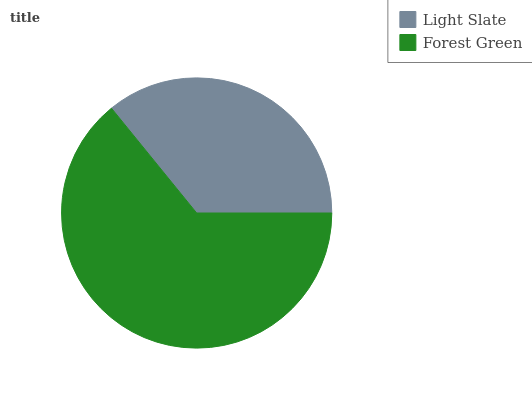Is Light Slate the minimum?
Answer yes or no. Yes. Is Forest Green the maximum?
Answer yes or no. Yes. Is Forest Green the minimum?
Answer yes or no. No. Is Forest Green greater than Light Slate?
Answer yes or no. Yes. Is Light Slate less than Forest Green?
Answer yes or no. Yes. Is Light Slate greater than Forest Green?
Answer yes or no. No. Is Forest Green less than Light Slate?
Answer yes or no. No. Is Forest Green the high median?
Answer yes or no. Yes. Is Light Slate the low median?
Answer yes or no. Yes. Is Light Slate the high median?
Answer yes or no. No. Is Forest Green the low median?
Answer yes or no. No. 